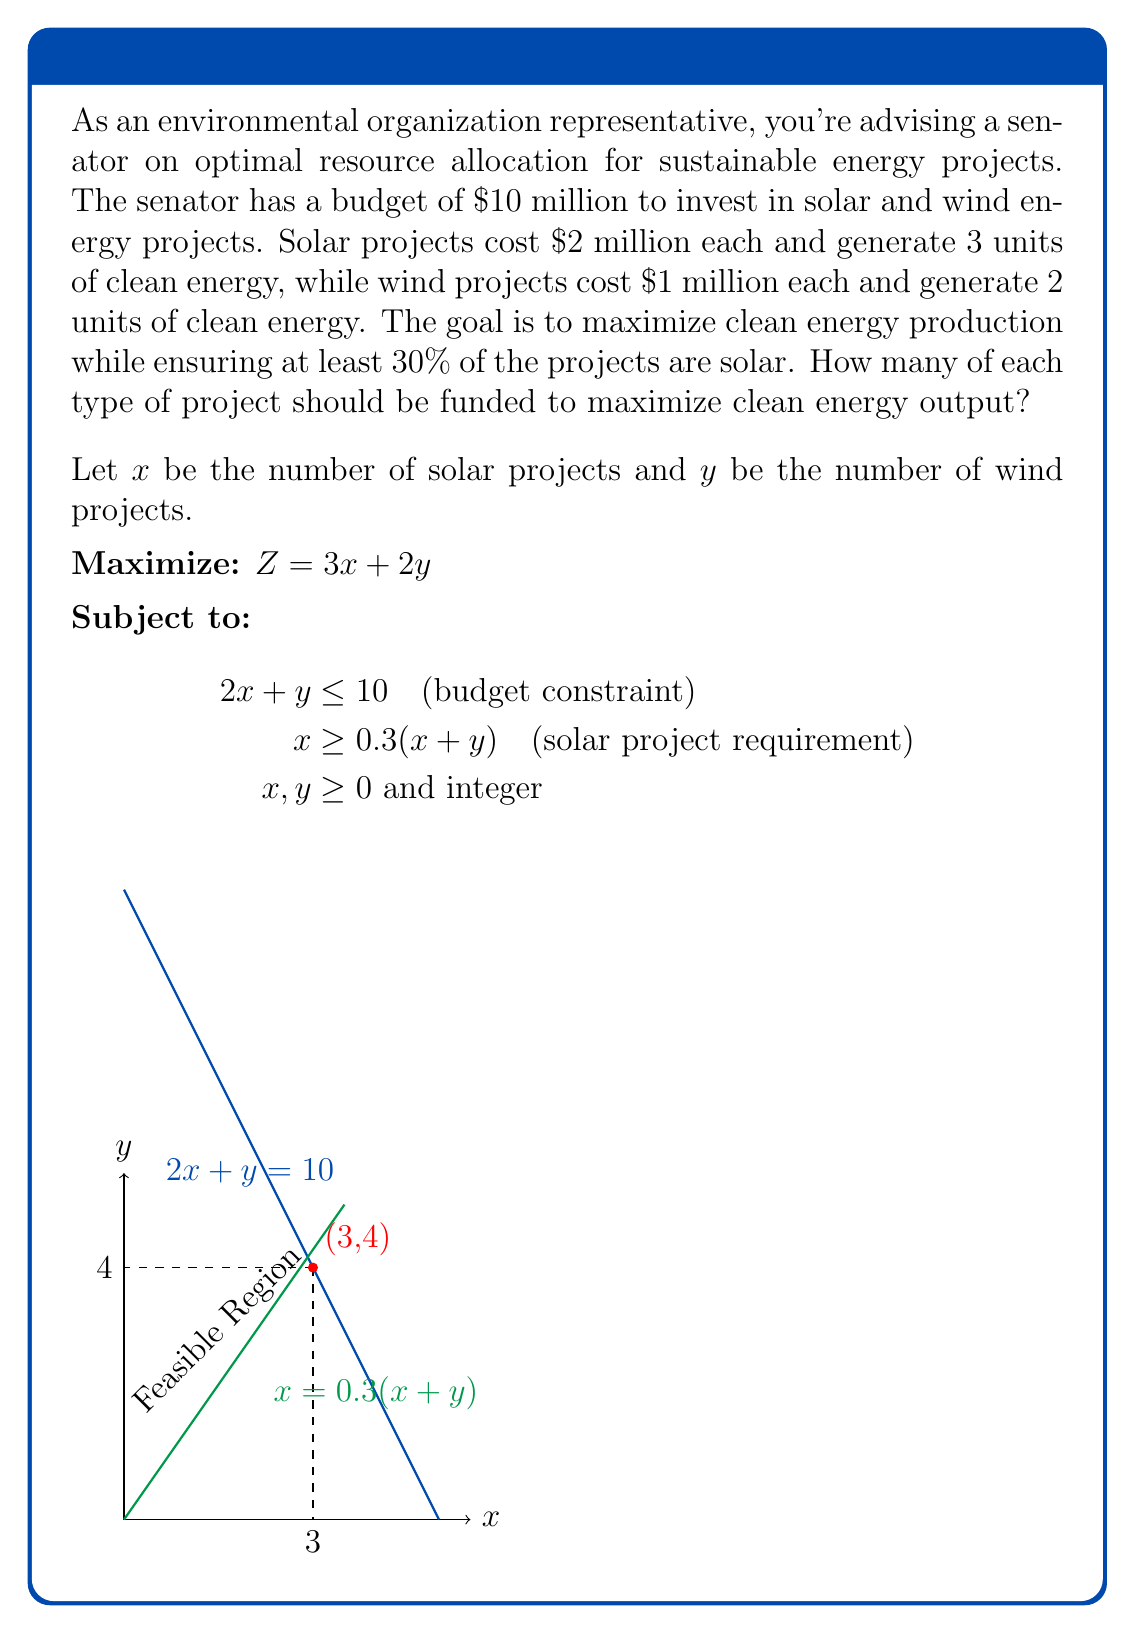What is the answer to this math problem? 1) First, we need to graph the constraints:
   - Budget constraint: $2x + y = 10$
   - Solar project requirement: $x = 0.3(x+y)$, which simplifies to $7x = 3y$

2) The feasible region is the area that satisfies both constraints and the non-negativity condition.

3) The corner points of the feasible region are:
   (0,0), (0,10), (5,0), and the intersection of the two constraint lines.

4) To find the intersection point, solve:
   $2x + y = 10$
   $7x = 3y$
   
   Substituting $y = \frac{7x}{3}$ into $2x + y = 10$:
   $2x + \frac{7x}{3} = 10$
   $6x + 7x = 30$
   $13x = 30$
   $x = \frac{30}{13} \approx 2.31$
   
   $y = 10 - 2x = 10 - 2(\frac{30}{13}) = \frac{70}{13} \approx 5.38$

5) Since we need integer solutions, we round down to (2,5) and up to (3,4).

6) Evaluate the objective function $Z = 3x + 2y$ at each feasible integer point:
   (0,0): $Z = 0$
   (0,10): $Z = 20$
   (5,0): $Z = 15$
   (2,5): $Z = 16$
   (3,4): $Z = 17$

7) The maximum value is achieved at (3,4), which satisfies all constraints.
Answer: 3 solar projects and 4 wind projects 